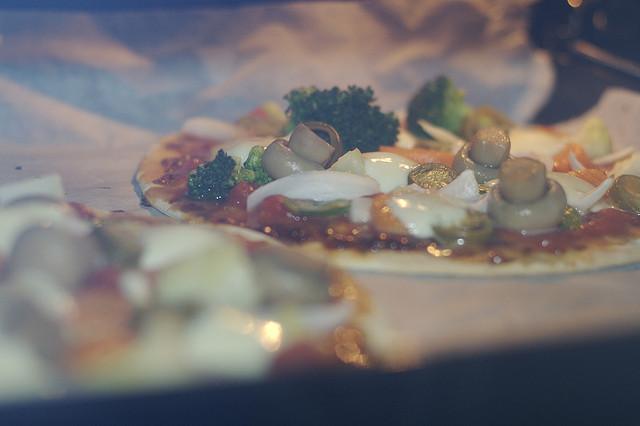What is the white vegetable shown on the pizza?
Keep it brief. Onion. Is this food ready?
Give a very brief answer. Yes. What is in the bowl?
Keep it brief. Pizza. Is there a hamburger on the plate?
Keep it brief. No. Is this a dessert item?
Be succinct. No. Has the meal started?
Be succinct. No. How many blueberries are on the plate?
Be succinct. 0. Are these vegetarian pizzas?
Quick response, please. Yes. Was the food served on plates?
Write a very short answer. No. 